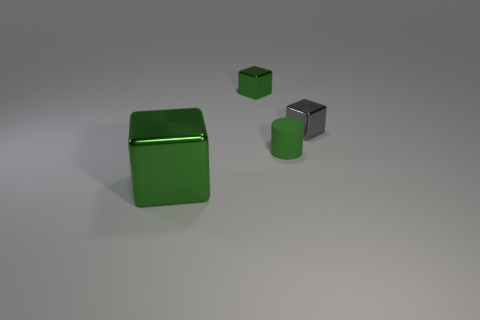Add 3 green matte objects. How many objects exist? 7 Subtract all cylinders. How many objects are left? 3 Add 1 green matte objects. How many green matte objects exist? 2 Subtract 0 purple blocks. How many objects are left? 4 Subtract all gray shiny blocks. Subtract all large green metallic cubes. How many objects are left? 2 Add 4 green objects. How many green objects are left? 7 